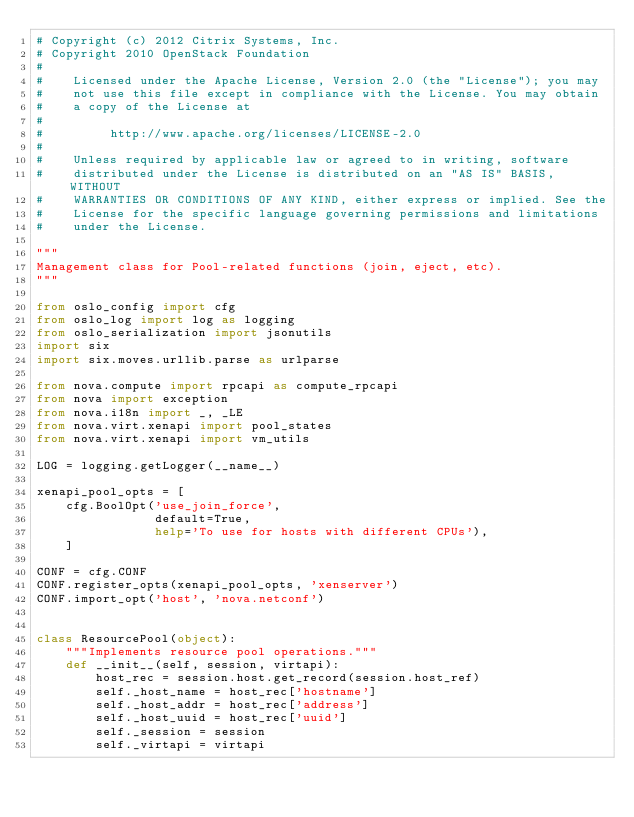Convert code to text. <code><loc_0><loc_0><loc_500><loc_500><_Python_># Copyright (c) 2012 Citrix Systems, Inc.
# Copyright 2010 OpenStack Foundation
#
#    Licensed under the Apache License, Version 2.0 (the "License"); you may
#    not use this file except in compliance with the License. You may obtain
#    a copy of the License at
#
#         http://www.apache.org/licenses/LICENSE-2.0
#
#    Unless required by applicable law or agreed to in writing, software
#    distributed under the License is distributed on an "AS IS" BASIS, WITHOUT
#    WARRANTIES OR CONDITIONS OF ANY KIND, either express or implied. See the
#    License for the specific language governing permissions and limitations
#    under the License.

"""
Management class for Pool-related functions (join, eject, etc).
"""

from oslo_config import cfg
from oslo_log import log as logging
from oslo_serialization import jsonutils
import six
import six.moves.urllib.parse as urlparse

from nova.compute import rpcapi as compute_rpcapi
from nova import exception
from nova.i18n import _, _LE
from nova.virt.xenapi import pool_states
from nova.virt.xenapi import vm_utils

LOG = logging.getLogger(__name__)

xenapi_pool_opts = [
    cfg.BoolOpt('use_join_force',
                default=True,
                help='To use for hosts with different CPUs'),
    ]

CONF = cfg.CONF
CONF.register_opts(xenapi_pool_opts, 'xenserver')
CONF.import_opt('host', 'nova.netconf')


class ResourcePool(object):
    """Implements resource pool operations."""
    def __init__(self, session, virtapi):
        host_rec = session.host.get_record(session.host_ref)
        self._host_name = host_rec['hostname']
        self._host_addr = host_rec['address']
        self._host_uuid = host_rec['uuid']
        self._session = session
        self._virtapi = virtapi</code> 